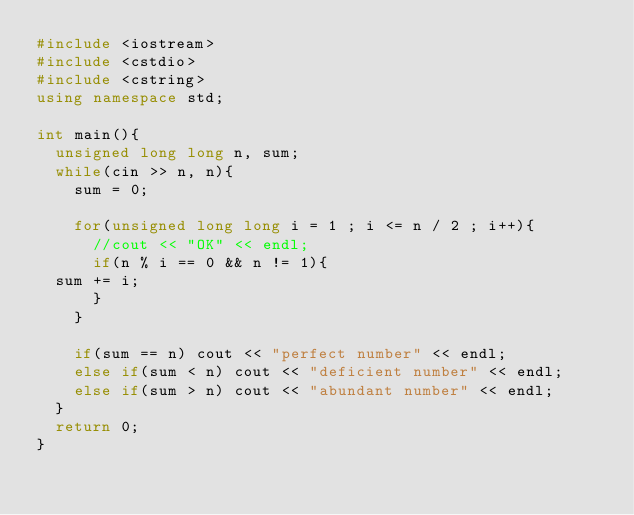<code> <loc_0><loc_0><loc_500><loc_500><_C++_>#include <iostream>
#include <cstdio>
#include <cstring>
using namespace std;

int main(){
  unsigned long long n, sum;
  while(cin >> n, n){
    sum = 0;
  
    for(unsigned long long i = 1 ; i <= n / 2 ; i++){
      //cout << "OK" << endl;
      if(n % i == 0 && n != 1){
	sum += i;
      }
    }
    
    if(sum == n) cout << "perfect number" << endl;
    else if(sum < n) cout << "deficient number" << endl;
    else if(sum > n) cout << "abundant number" << endl;
  }
  return 0;
}</code> 